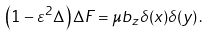Convert formula to latex. <formula><loc_0><loc_0><loc_500><loc_500>\left ( 1 - \varepsilon ^ { 2 } \Delta \right ) \Delta F = \mu b _ { z } \delta ( x ) \delta ( y ) \, .</formula> 